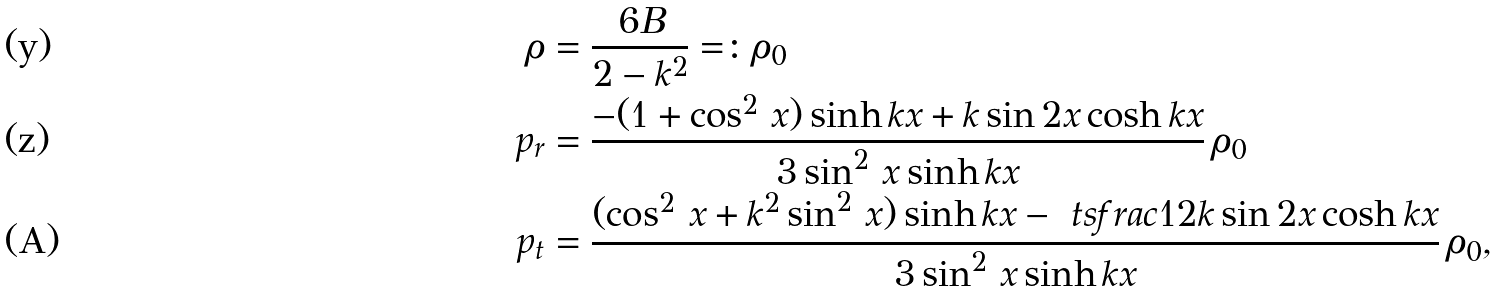Convert formula to latex. <formula><loc_0><loc_0><loc_500><loc_500>\rho & = \frac { 6 B } { 2 - k ^ { 2 } } = \colon \rho _ { 0 } \\ p _ { r } & = \frac { - ( 1 + \cos ^ { 2 } \, x ) \sinh { k x } + k \sin { 2 x } \cosh { k x } } { 3 \sin ^ { 2 } \, x \sinh { k x } } \, \rho _ { 0 } \\ p _ { t } & = \frac { ( \cos ^ { 2 } \, x + k ^ { 2 } \sin ^ { 2 } \, x ) \sinh { k x } - \ t s f r a c 1 2 k \sin { 2 x } \cosh { k x } } { 3 \sin ^ { 2 } \, x \sinh { k x } } \, \rho _ { 0 } ,</formula> 